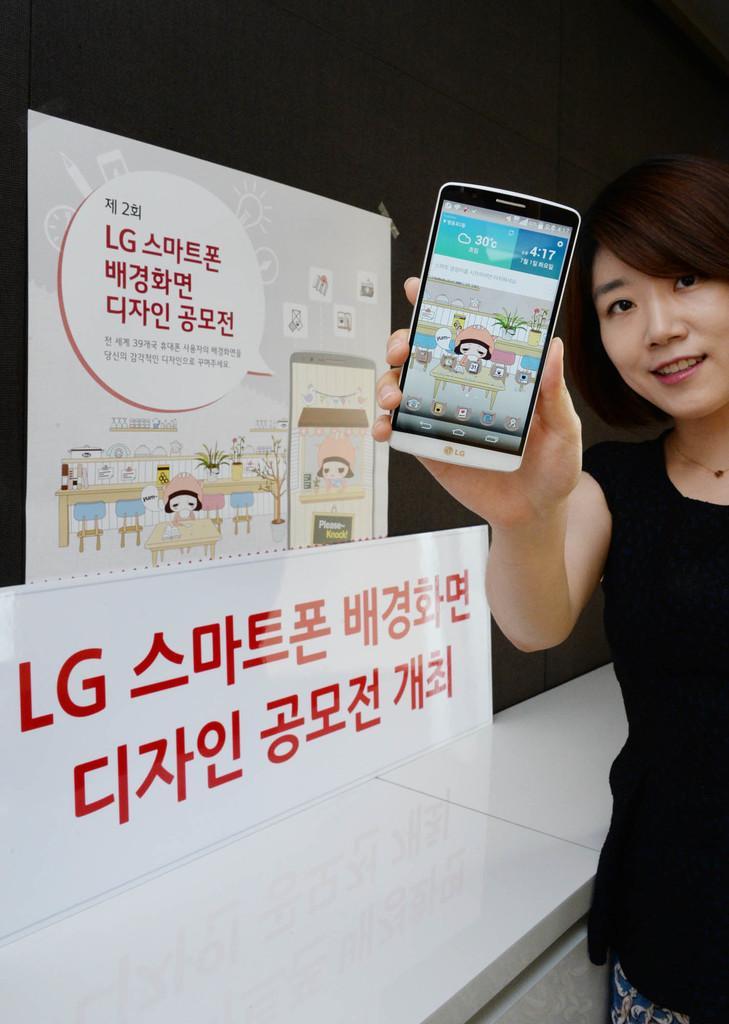Could you give a brief overview of what you see in this image? In this picture we can see a woman she is holding mobile in her hand, we can see a hoarding in the background. 